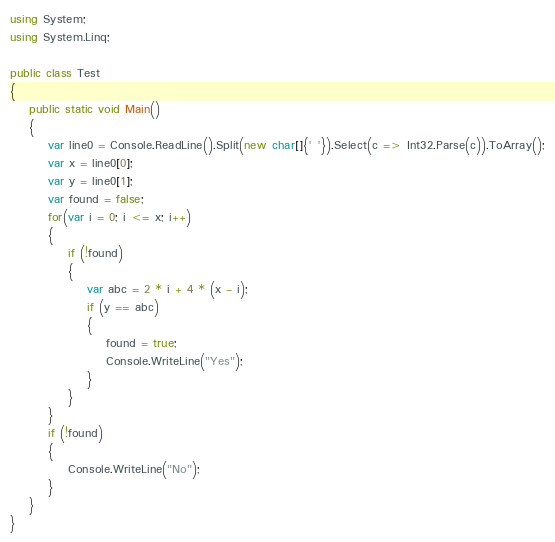Convert code to text. <code><loc_0><loc_0><loc_500><loc_500><_C#_>using System;
using System.Linq;

public class Test
{
	public static void Main()
	{
		var line0 = Console.ReadLine().Split(new char[]{' '}).Select(c => Int32.Parse(c)).ToArray();
		var x = line0[0];
		var y = line0[1];
		var found = false;
		for(var i = 0; i <= x; i++)
		{
			if (!found)
			{
				var abc = 2 * i + 4 * (x - i);
				if (y == abc)
				{
					found = true;
					Console.WriteLine("Yes");
				}
			}
		}
		if (!found)
		{
			Console.WriteLine("No");
		}
	}
}
</code> 